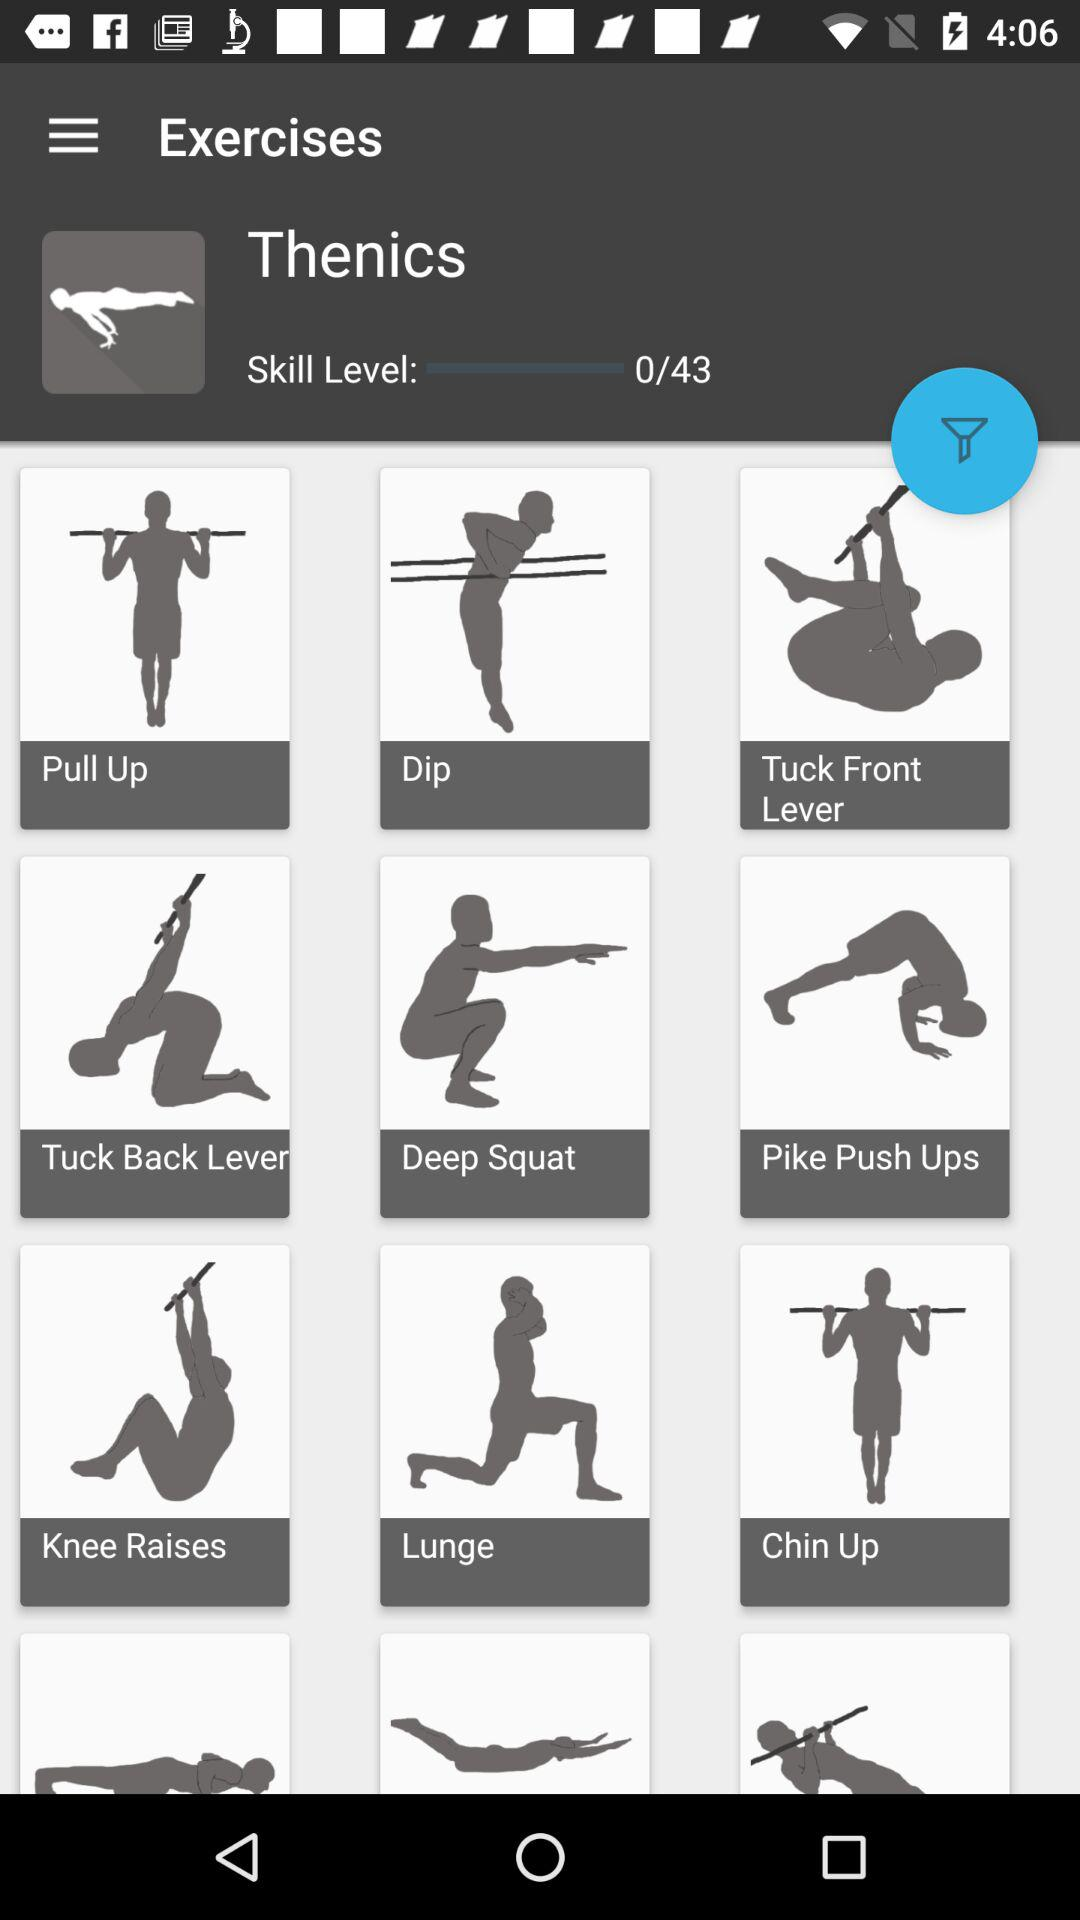How many exercises are there in total?
Answer the question using a single word or phrase. 43 